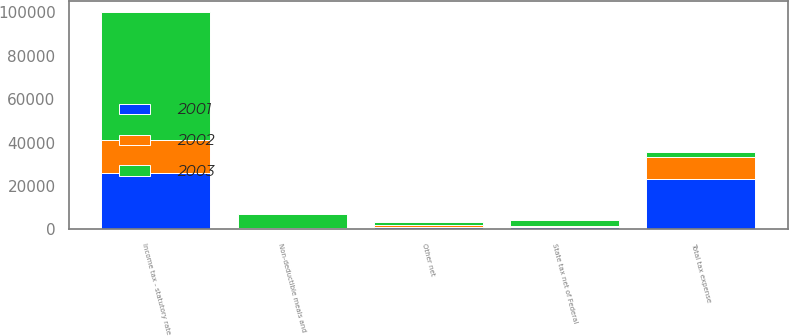Convert chart to OTSL. <chart><loc_0><loc_0><loc_500><loc_500><stacked_bar_chart><ecel><fcel>Income tax - statutory rate<fcel>State tax net of Federal<fcel>Non-deductible meals and<fcel>Other net<fcel>Total tax expense<nl><fcel>2003<fcel>58706<fcel>3019<fcel>6694<fcel>1636<fcel>2327.5<nl><fcel>2001<fcel>26196<fcel>1295<fcel>285<fcel>1238<fcel>23031<nl><fcel>2002<fcel>15078<fcel>174<fcel>208<fcel>715<fcel>10137<nl></chart> 